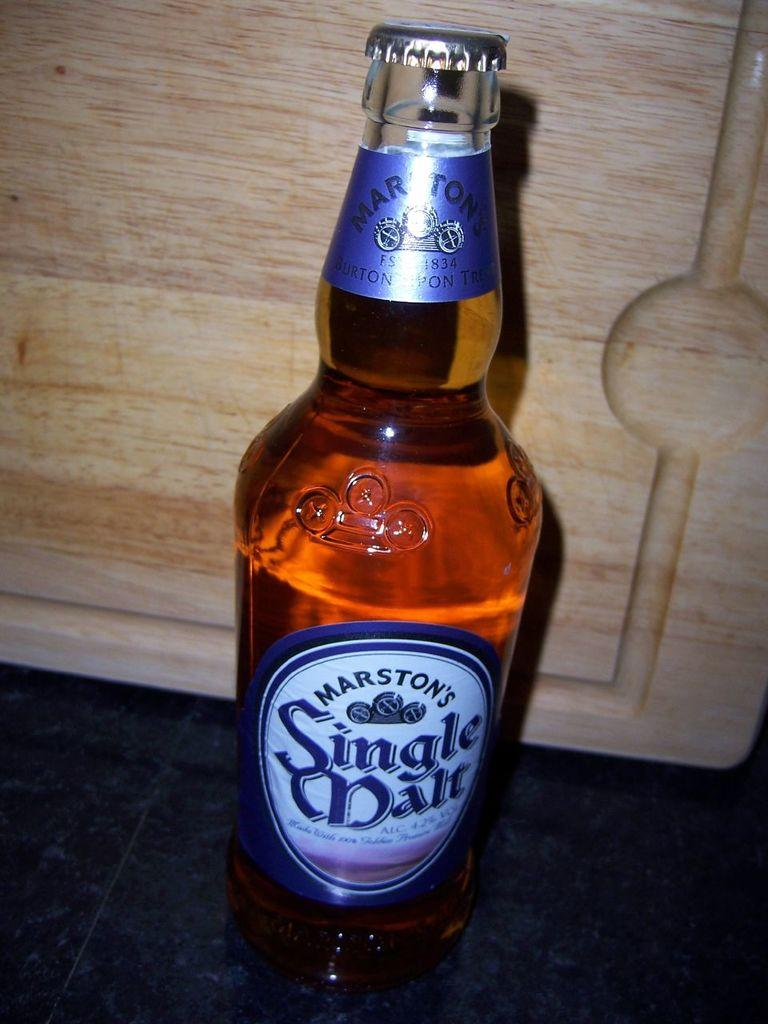<image>
Summarize the visual content of the image. an un opened bottled of Marston's Single malt beer. 